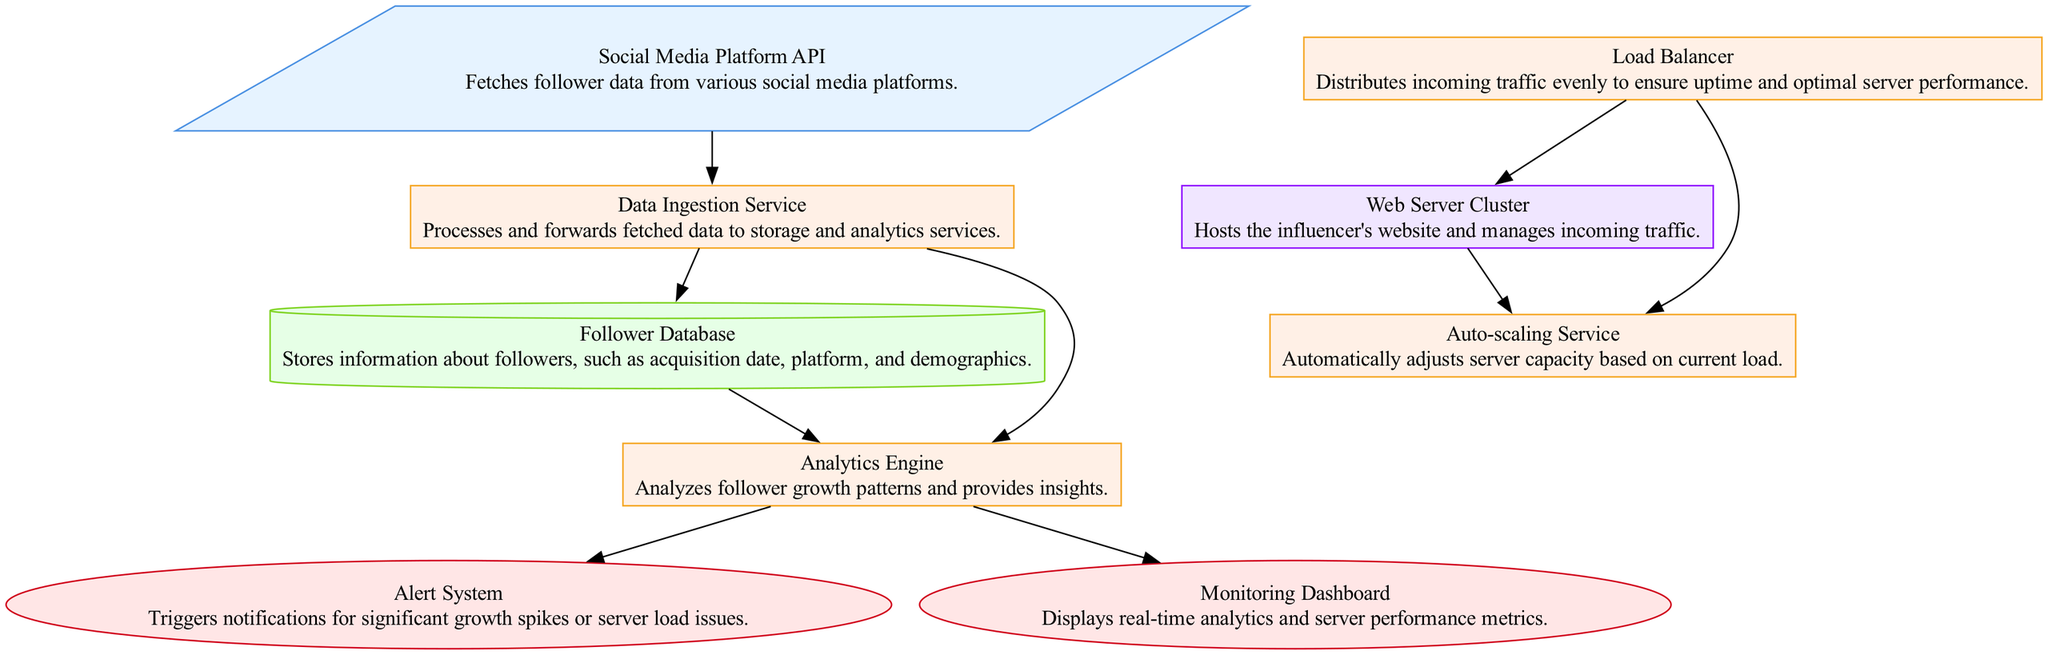What is the input source for follower data? The diagram indicates that the "Social Media Platform API" is the input source responsible for fetching follower data from various social media platforms.
Answer: Social Media Platform API How many processing units are in the diagram? The diagram includes five processing units: "Data Ingestion Service," "Analytics Engine," "Load Balancer," "Auto-scaling Service," and "Web Server Cluster."
Answer: Five What triggers notifications for significant growth spikes? The "Alert System" is the component responsible for triggering notifications when there are significant growth spikes or server load issues.
Answer: Alert System Which component ensures even distribution of incoming traffic? The "Load Balancer" is specifically designed to distribute incoming traffic evenly to maintain optimal server performance and uptime.
Answer: Load Balancer What connects the Follower Database to the Analytics Engine? The connection between the "Follower Database" and the "Analytics Engine" is established through a direct edge, indicating that the Analytics Engine analyzes data stored in the Follower Database.
Answer: Edge Which service automatically adjusts server capacity? The "Auto-scaling Service" automatically adjusts server capacity in response to the current load, ensuring efficiency in resource management.
Answer: Auto-scaling Service What is displayed on the Monitoring Dashboard? The "Monitoring Dashboard" displays real-time analytics and server performance metrics, allowing users to monitor system status effectively.
Answer: Real-time analytics How does the Load Balancer relate to the Web Server Cluster? The Load Balancer distributes traffic to the Web Server Cluster, ensuring that incoming user requests are managed efficiently across the clustered web servers.
Answer: Distributes traffic What action does the Analytics Engine perform after analyzing data? After analyzing follower data, the Analytics Engine provides insights, which are utilized by both the Alert System and the Monitoring Dashboard.
Answer: Provides insights What is the purpose of the Data Ingestion Service? The Data Ingestion Service processes and forwards fetched follower data to both storage and analytics services, serving as a bridge between raw data and its functional use.
Answer: Processes and forwards data 